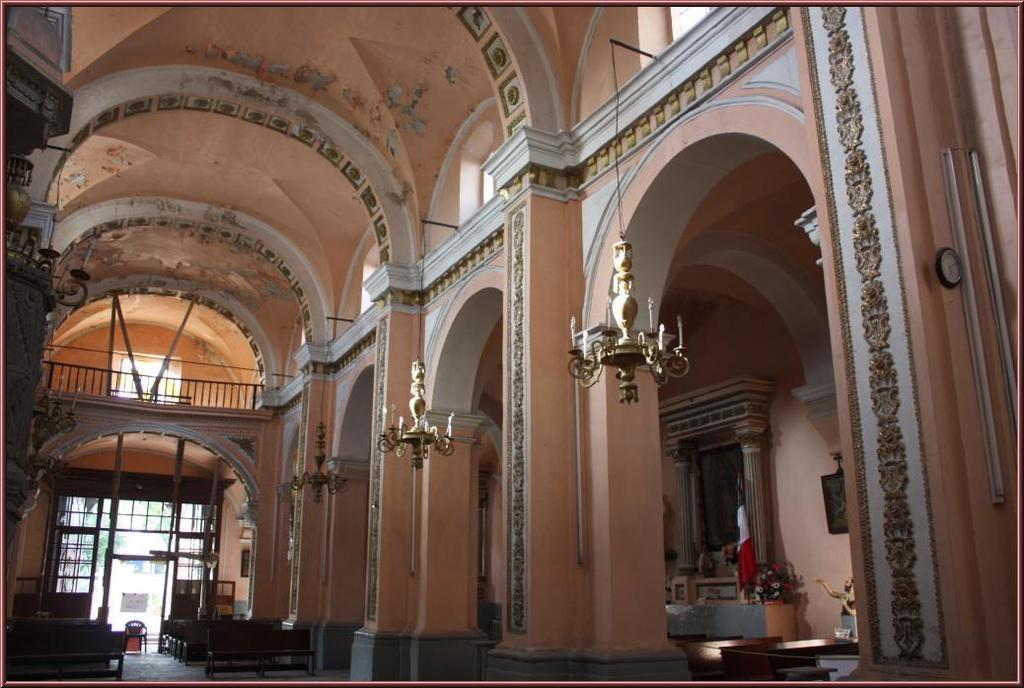What type of structure is visible in the image? There is a building in the image. What type of lighting is present in the building? The building has chandeliers. What type of seating is available in the building? The building has benches. What type of sticks are used for camping in the image? There is no camping or sticks present in the image; it features a building with chandeliers and benches. How many legs does the building have in the image? The building is a solid structure and does not have legs; it stands on a foundation. 